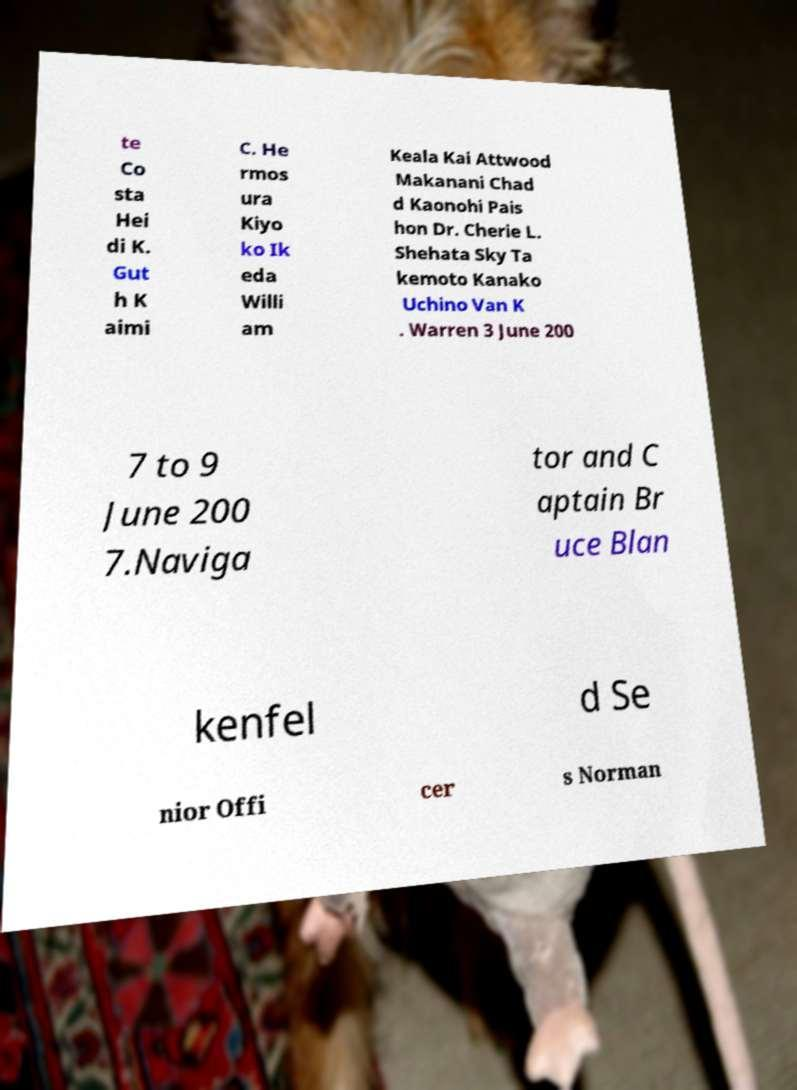Can you accurately transcribe the text from the provided image for me? te Co sta Hei di K. Gut h K aimi C. He rmos ura Kiyo ko Ik eda Willi am Keala Kai Attwood Makanani Chad d Kaonohi Pais hon Dr. Cherie L. Shehata Sky Ta kemoto Kanako Uchino Van K . Warren 3 June 200 7 to 9 June 200 7.Naviga tor and C aptain Br uce Blan kenfel d Se nior Offi cer s Norman 